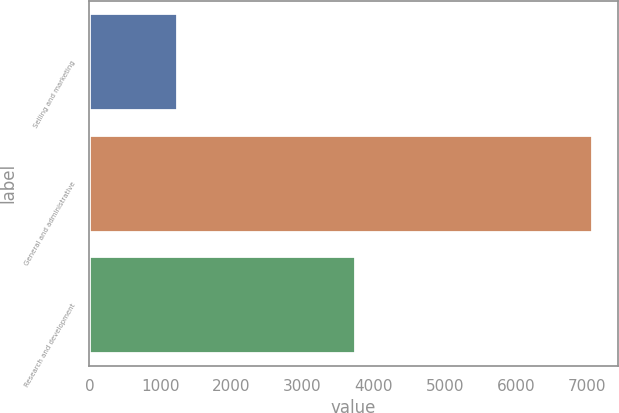<chart> <loc_0><loc_0><loc_500><loc_500><bar_chart><fcel>Selling and marketing<fcel>General and administrative<fcel>Research and development<nl><fcel>1232<fcel>7080<fcel>3735<nl></chart> 